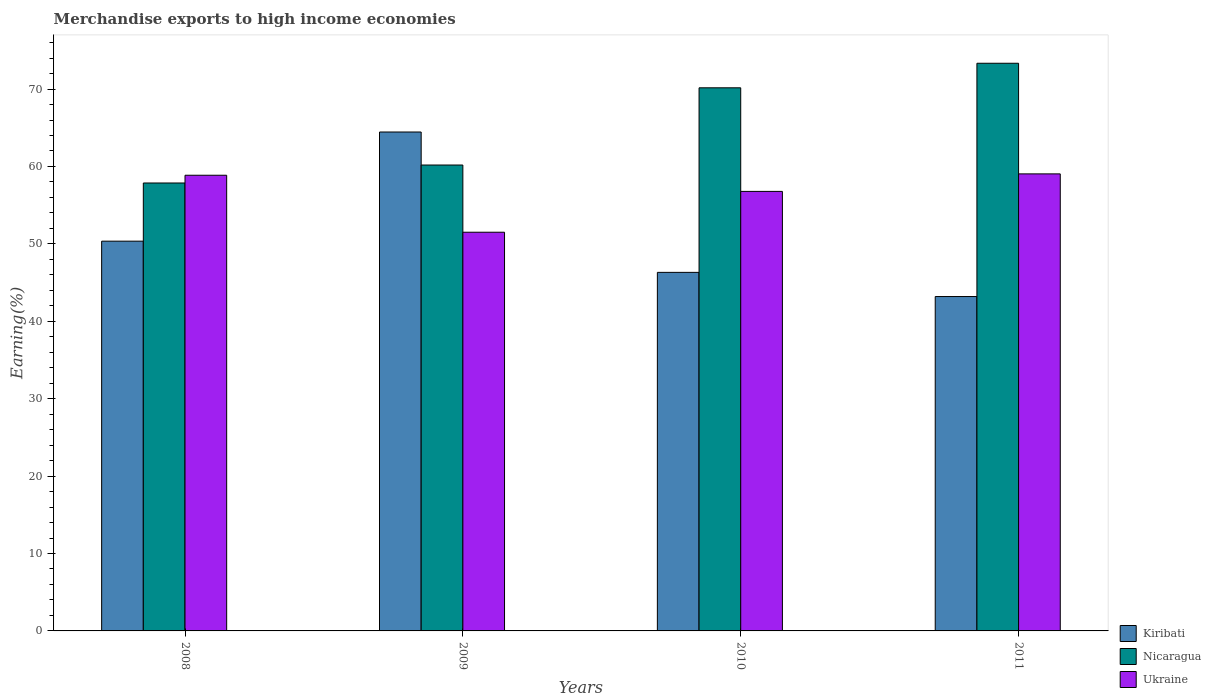How many different coloured bars are there?
Your response must be concise. 3. How many groups of bars are there?
Keep it short and to the point. 4. How many bars are there on the 2nd tick from the left?
Offer a terse response. 3. How many bars are there on the 3rd tick from the right?
Give a very brief answer. 3. What is the label of the 4th group of bars from the left?
Ensure brevity in your answer.  2011. What is the percentage of amount earned from merchandise exports in Nicaragua in 2011?
Make the answer very short. 73.33. Across all years, what is the maximum percentage of amount earned from merchandise exports in Kiribati?
Give a very brief answer. 64.45. Across all years, what is the minimum percentage of amount earned from merchandise exports in Ukraine?
Ensure brevity in your answer.  51.51. In which year was the percentage of amount earned from merchandise exports in Kiribati minimum?
Give a very brief answer. 2011. What is the total percentage of amount earned from merchandise exports in Ukraine in the graph?
Your answer should be compact. 226.2. What is the difference between the percentage of amount earned from merchandise exports in Kiribati in 2008 and that in 2009?
Make the answer very short. -14.1. What is the difference between the percentage of amount earned from merchandise exports in Nicaragua in 2008 and the percentage of amount earned from merchandise exports in Kiribati in 2011?
Provide a short and direct response. 14.67. What is the average percentage of amount earned from merchandise exports in Kiribati per year?
Your answer should be compact. 51.08. In the year 2011, what is the difference between the percentage of amount earned from merchandise exports in Nicaragua and percentage of amount earned from merchandise exports in Ukraine?
Provide a short and direct response. 14.29. In how many years, is the percentage of amount earned from merchandise exports in Nicaragua greater than 10 %?
Provide a short and direct response. 4. What is the ratio of the percentage of amount earned from merchandise exports in Nicaragua in 2008 to that in 2011?
Give a very brief answer. 0.79. Is the percentage of amount earned from merchandise exports in Ukraine in 2008 less than that in 2009?
Offer a very short reply. No. Is the difference between the percentage of amount earned from merchandise exports in Nicaragua in 2008 and 2010 greater than the difference between the percentage of amount earned from merchandise exports in Ukraine in 2008 and 2010?
Your response must be concise. No. What is the difference between the highest and the second highest percentage of amount earned from merchandise exports in Nicaragua?
Give a very brief answer. 3.17. What is the difference between the highest and the lowest percentage of amount earned from merchandise exports in Kiribati?
Make the answer very short. 21.25. What does the 3rd bar from the left in 2009 represents?
Your answer should be very brief. Ukraine. What does the 2nd bar from the right in 2008 represents?
Provide a short and direct response. Nicaragua. How many years are there in the graph?
Provide a succinct answer. 4. Are the values on the major ticks of Y-axis written in scientific E-notation?
Offer a terse response. No. Does the graph contain any zero values?
Offer a terse response. No. Does the graph contain grids?
Offer a very short reply. No. How are the legend labels stacked?
Give a very brief answer. Vertical. What is the title of the graph?
Make the answer very short. Merchandise exports to high income economies. Does "Antigua and Barbuda" appear as one of the legend labels in the graph?
Ensure brevity in your answer.  No. What is the label or title of the X-axis?
Offer a terse response. Years. What is the label or title of the Y-axis?
Your response must be concise. Earning(%). What is the Earning(%) in Kiribati in 2008?
Your answer should be compact. 50.35. What is the Earning(%) in Nicaragua in 2008?
Ensure brevity in your answer.  57.87. What is the Earning(%) in Ukraine in 2008?
Your response must be concise. 58.87. What is the Earning(%) in Kiribati in 2009?
Your response must be concise. 64.45. What is the Earning(%) of Nicaragua in 2009?
Your answer should be compact. 60.19. What is the Earning(%) of Ukraine in 2009?
Offer a terse response. 51.51. What is the Earning(%) in Kiribati in 2010?
Your answer should be very brief. 46.32. What is the Earning(%) of Nicaragua in 2010?
Offer a very short reply. 70.16. What is the Earning(%) in Ukraine in 2010?
Provide a succinct answer. 56.78. What is the Earning(%) of Kiribati in 2011?
Offer a very short reply. 43.2. What is the Earning(%) in Nicaragua in 2011?
Your answer should be very brief. 73.33. What is the Earning(%) in Ukraine in 2011?
Your answer should be very brief. 59.04. Across all years, what is the maximum Earning(%) of Kiribati?
Give a very brief answer. 64.45. Across all years, what is the maximum Earning(%) of Nicaragua?
Your answer should be compact. 73.33. Across all years, what is the maximum Earning(%) of Ukraine?
Your answer should be compact. 59.04. Across all years, what is the minimum Earning(%) in Kiribati?
Offer a very short reply. 43.2. Across all years, what is the minimum Earning(%) in Nicaragua?
Keep it short and to the point. 57.87. Across all years, what is the minimum Earning(%) in Ukraine?
Give a very brief answer. 51.51. What is the total Earning(%) of Kiribati in the graph?
Keep it short and to the point. 204.32. What is the total Earning(%) in Nicaragua in the graph?
Offer a very short reply. 261.55. What is the total Earning(%) of Ukraine in the graph?
Offer a very short reply. 226.2. What is the difference between the Earning(%) of Kiribati in 2008 and that in 2009?
Keep it short and to the point. -14.1. What is the difference between the Earning(%) of Nicaragua in 2008 and that in 2009?
Your answer should be compact. -2.32. What is the difference between the Earning(%) in Ukraine in 2008 and that in 2009?
Your answer should be very brief. 7.36. What is the difference between the Earning(%) in Kiribati in 2008 and that in 2010?
Ensure brevity in your answer.  4.03. What is the difference between the Earning(%) of Nicaragua in 2008 and that in 2010?
Ensure brevity in your answer.  -12.3. What is the difference between the Earning(%) of Ukraine in 2008 and that in 2010?
Your response must be concise. 2.09. What is the difference between the Earning(%) in Kiribati in 2008 and that in 2011?
Give a very brief answer. 7.15. What is the difference between the Earning(%) in Nicaragua in 2008 and that in 2011?
Offer a very short reply. -15.47. What is the difference between the Earning(%) in Ukraine in 2008 and that in 2011?
Keep it short and to the point. -0.17. What is the difference between the Earning(%) in Kiribati in 2009 and that in 2010?
Provide a short and direct response. 18.13. What is the difference between the Earning(%) of Nicaragua in 2009 and that in 2010?
Keep it short and to the point. -9.98. What is the difference between the Earning(%) of Ukraine in 2009 and that in 2010?
Provide a succinct answer. -5.27. What is the difference between the Earning(%) of Kiribati in 2009 and that in 2011?
Provide a short and direct response. 21.25. What is the difference between the Earning(%) of Nicaragua in 2009 and that in 2011?
Give a very brief answer. -13.15. What is the difference between the Earning(%) of Ukraine in 2009 and that in 2011?
Ensure brevity in your answer.  -7.54. What is the difference between the Earning(%) in Kiribati in 2010 and that in 2011?
Give a very brief answer. 3.12. What is the difference between the Earning(%) of Nicaragua in 2010 and that in 2011?
Your answer should be very brief. -3.17. What is the difference between the Earning(%) of Ukraine in 2010 and that in 2011?
Your answer should be compact. -2.26. What is the difference between the Earning(%) of Kiribati in 2008 and the Earning(%) of Nicaragua in 2009?
Provide a short and direct response. -9.84. What is the difference between the Earning(%) in Kiribati in 2008 and the Earning(%) in Ukraine in 2009?
Offer a terse response. -1.16. What is the difference between the Earning(%) in Nicaragua in 2008 and the Earning(%) in Ukraine in 2009?
Your response must be concise. 6.36. What is the difference between the Earning(%) in Kiribati in 2008 and the Earning(%) in Nicaragua in 2010?
Give a very brief answer. -19.81. What is the difference between the Earning(%) of Kiribati in 2008 and the Earning(%) of Ukraine in 2010?
Your answer should be compact. -6.43. What is the difference between the Earning(%) in Nicaragua in 2008 and the Earning(%) in Ukraine in 2010?
Keep it short and to the point. 1.09. What is the difference between the Earning(%) of Kiribati in 2008 and the Earning(%) of Nicaragua in 2011?
Provide a succinct answer. -22.98. What is the difference between the Earning(%) in Kiribati in 2008 and the Earning(%) in Ukraine in 2011?
Offer a terse response. -8.69. What is the difference between the Earning(%) in Nicaragua in 2008 and the Earning(%) in Ukraine in 2011?
Provide a succinct answer. -1.18. What is the difference between the Earning(%) of Kiribati in 2009 and the Earning(%) of Nicaragua in 2010?
Provide a short and direct response. -5.71. What is the difference between the Earning(%) of Kiribati in 2009 and the Earning(%) of Ukraine in 2010?
Offer a terse response. 7.67. What is the difference between the Earning(%) of Nicaragua in 2009 and the Earning(%) of Ukraine in 2010?
Give a very brief answer. 3.41. What is the difference between the Earning(%) of Kiribati in 2009 and the Earning(%) of Nicaragua in 2011?
Provide a short and direct response. -8.88. What is the difference between the Earning(%) in Kiribati in 2009 and the Earning(%) in Ukraine in 2011?
Provide a short and direct response. 5.41. What is the difference between the Earning(%) of Nicaragua in 2009 and the Earning(%) of Ukraine in 2011?
Provide a short and direct response. 1.14. What is the difference between the Earning(%) of Kiribati in 2010 and the Earning(%) of Nicaragua in 2011?
Offer a terse response. -27.01. What is the difference between the Earning(%) of Kiribati in 2010 and the Earning(%) of Ukraine in 2011?
Offer a terse response. -12.72. What is the difference between the Earning(%) of Nicaragua in 2010 and the Earning(%) of Ukraine in 2011?
Offer a very short reply. 11.12. What is the average Earning(%) of Kiribati per year?
Offer a very short reply. 51.08. What is the average Earning(%) in Nicaragua per year?
Give a very brief answer. 65.39. What is the average Earning(%) in Ukraine per year?
Provide a succinct answer. 56.55. In the year 2008, what is the difference between the Earning(%) of Kiribati and Earning(%) of Nicaragua?
Provide a succinct answer. -7.52. In the year 2008, what is the difference between the Earning(%) in Kiribati and Earning(%) in Ukraine?
Your answer should be very brief. -8.52. In the year 2008, what is the difference between the Earning(%) of Nicaragua and Earning(%) of Ukraine?
Make the answer very short. -1. In the year 2009, what is the difference between the Earning(%) in Kiribati and Earning(%) in Nicaragua?
Keep it short and to the point. 4.27. In the year 2009, what is the difference between the Earning(%) of Kiribati and Earning(%) of Ukraine?
Your response must be concise. 12.95. In the year 2009, what is the difference between the Earning(%) in Nicaragua and Earning(%) in Ukraine?
Make the answer very short. 8.68. In the year 2010, what is the difference between the Earning(%) in Kiribati and Earning(%) in Nicaragua?
Your answer should be compact. -23.84. In the year 2010, what is the difference between the Earning(%) in Kiribati and Earning(%) in Ukraine?
Offer a terse response. -10.46. In the year 2010, what is the difference between the Earning(%) in Nicaragua and Earning(%) in Ukraine?
Provide a short and direct response. 13.38. In the year 2011, what is the difference between the Earning(%) in Kiribati and Earning(%) in Nicaragua?
Offer a terse response. -30.14. In the year 2011, what is the difference between the Earning(%) in Kiribati and Earning(%) in Ukraine?
Offer a very short reply. -15.84. In the year 2011, what is the difference between the Earning(%) of Nicaragua and Earning(%) of Ukraine?
Provide a short and direct response. 14.29. What is the ratio of the Earning(%) of Kiribati in 2008 to that in 2009?
Keep it short and to the point. 0.78. What is the ratio of the Earning(%) in Nicaragua in 2008 to that in 2009?
Your answer should be compact. 0.96. What is the ratio of the Earning(%) of Ukraine in 2008 to that in 2009?
Offer a very short reply. 1.14. What is the ratio of the Earning(%) of Kiribati in 2008 to that in 2010?
Keep it short and to the point. 1.09. What is the ratio of the Earning(%) of Nicaragua in 2008 to that in 2010?
Give a very brief answer. 0.82. What is the ratio of the Earning(%) of Ukraine in 2008 to that in 2010?
Make the answer very short. 1.04. What is the ratio of the Earning(%) in Kiribati in 2008 to that in 2011?
Offer a terse response. 1.17. What is the ratio of the Earning(%) of Nicaragua in 2008 to that in 2011?
Your response must be concise. 0.79. What is the ratio of the Earning(%) in Kiribati in 2009 to that in 2010?
Provide a short and direct response. 1.39. What is the ratio of the Earning(%) in Nicaragua in 2009 to that in 2010?
Offer a very short reply. 0.86. What is the ratio of the Earning(%) of Ukraine in 2009 to that in 2010?
Make the answer very short. 0.91. What is the ratio of the Earning(%) of Kiribati in 2009 to that in 2011?
Your answer should be very brief. 1.49. What is the ratio of the Earning(%) in Nicaragua in 2009 to that in 2011?
Your answer should be very brief. 0.82. What is the ratio of the Earning(%) of Ukraine in 2009 to that in 2011?
Your answer should be compact. 0.87. What is the ratio of the Earning(%) of Kiribati in 2010 to that in 2011?
Make the answer very short. 1.07. What is the ratio of the Earning(%) in Nicaragua in 2010 to that in 2011?
Provide a succinct answer. 0.96. What is the ratio of the Earning(%) in Ukraine in 2010 to that in 2011?
Make the answer very short. 0.96. What is the difference between the highest and the second highest Earning(%) in Kiribati?
Offer a very short reply. 14.1. What is the difference between the highest and the second highest Earning(%) in Nicaragua?
Give a very brief answer. 3.17. What is the difference between the highest and the second highest Earning(%) of Ukraine?
Provide a succinct answer. 0.17. What is the difference between the highest and the lowest Earning(%) in Kiribati?
Your response must be concise. 21.25. What is the difference between the highest and the lowest Earning(%) of Nicaragua?
Offer a very short reply. 15.47. What is the difference between the highest and the lowest Earning(%) in Ukraine?
Ensure brevity in your answer.  7.54. 